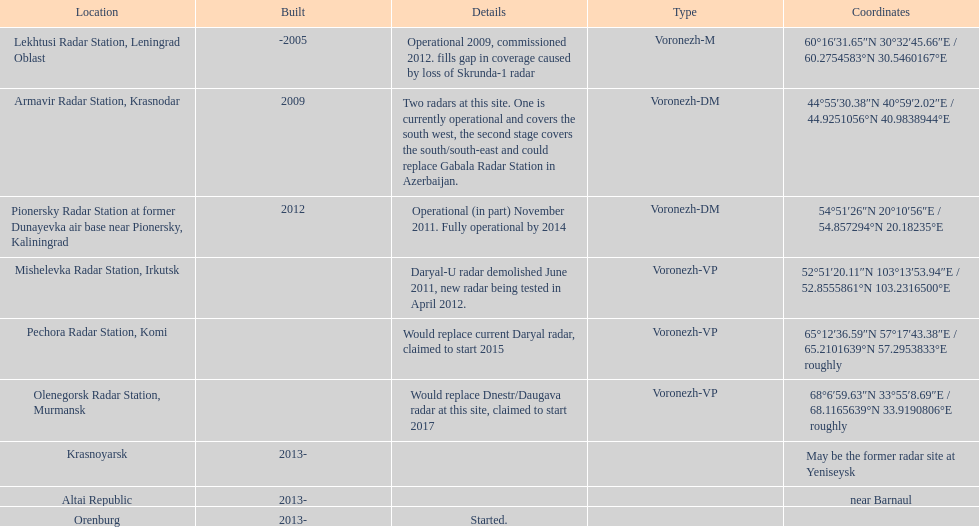Before the year 2010, what was the total count of voronezh radars that had been built? 2. 